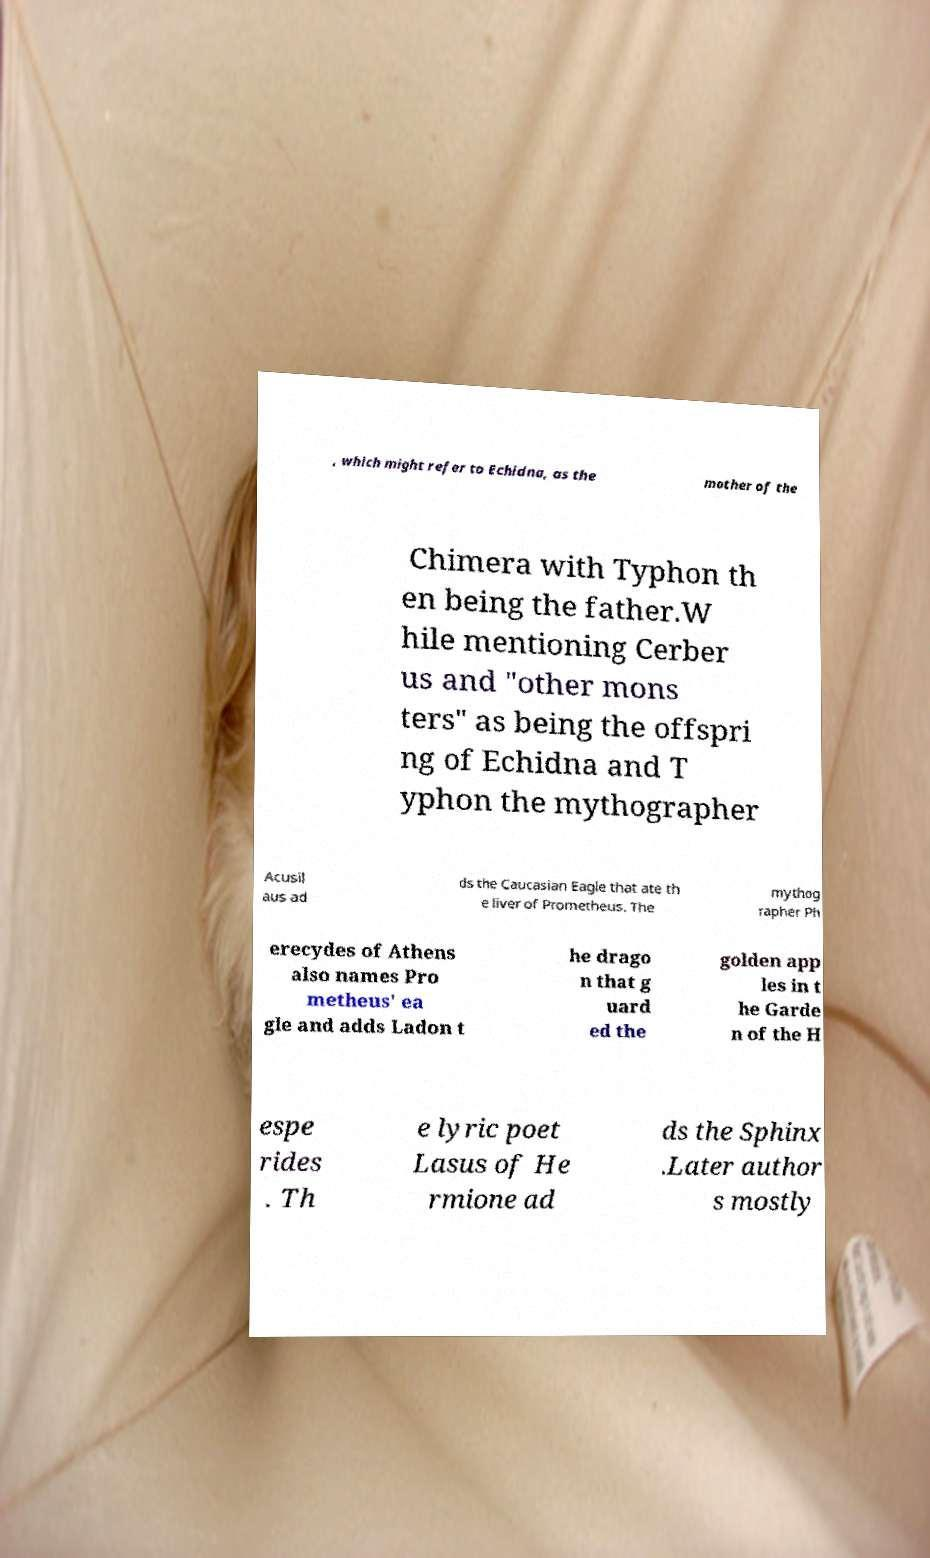Could you assist in decoding the text presented in this image and type it out clearly? , which might refer to Echidna, as the mother of the Chimera with Typhon th en being the father.W hile mentioning Cerber us and "other mons ters" as being the offspri ng of Echidna and T yphon the mythographer Acusil aus ad ds the Caucasian Eagle that ate th e liver of Prometheus. The mythog rapher Ph erecydes of Athens also names Pro metheus' ea gle and adds Ladon t he drago n that g uard ed the golden app les in t he Garde n of the H espe rides . Th e lyric poet Lasus of He rmione ad ds the Sphinx .Later author s mostly 